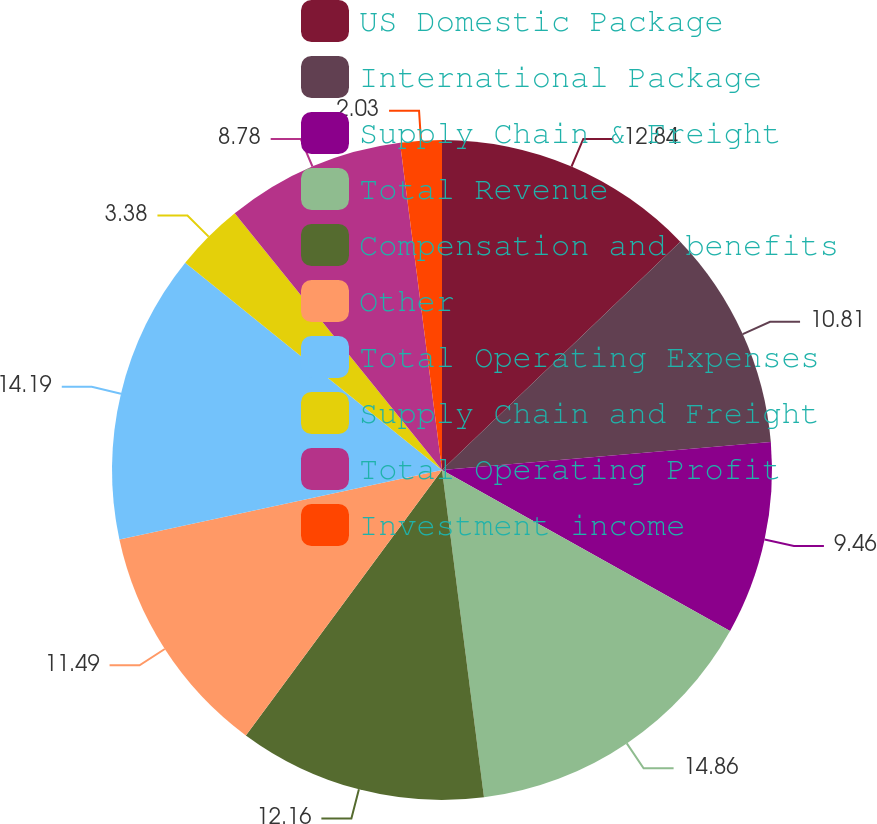Convert chart to OTSL. <chart><loc_0><loc_0><loc_500><loc_500><pie_chart><fcel>US Domestic Package<fcel>International Package<fcel>Supply Chain & Freight<fcel>Total Revenue<fcel>Compensation and benefits<fcel>Other<fcel>Total Operating Expenses<fcel>Supply Chain and Freight<fcel>Total Operating Profit<fcel>Investment income<nl><fcel>12.84%<fcel>10.81%<fcel>9.46%<fcel>14.86%<fcel>12.16%<fcel>11.49%<fcel>14.19%<fcel>3.38%<fcel>8.78%<fcel>2.03%<nl></chart> 